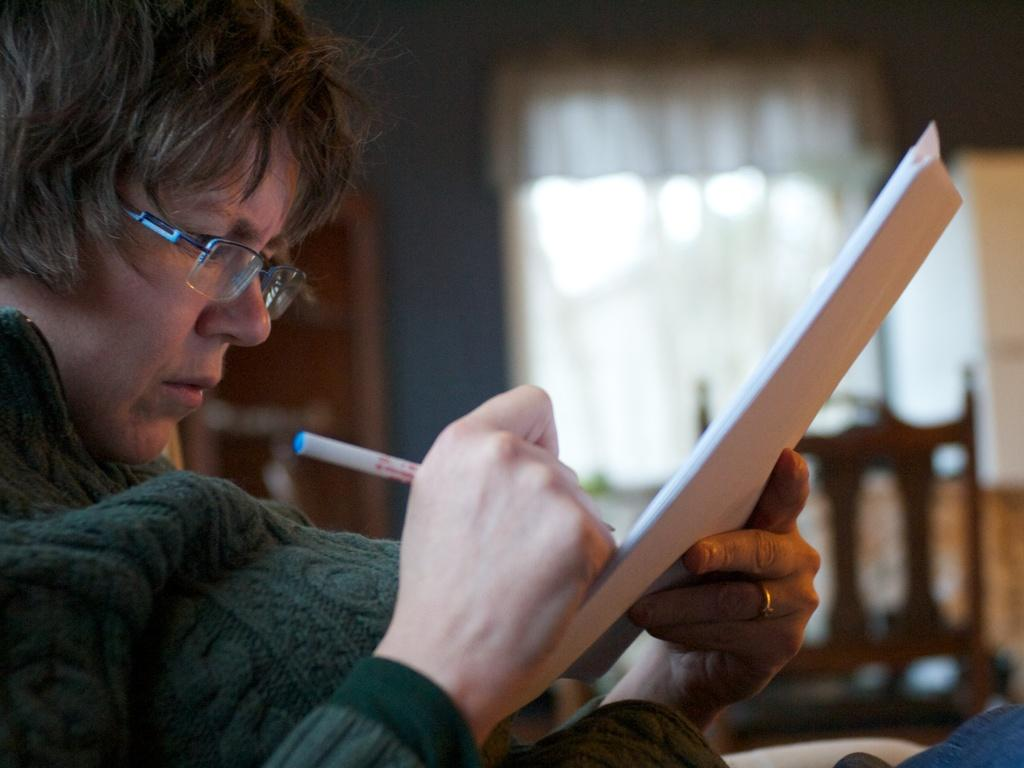Who is present in the image? There is a person in the image. What can be observed about the person's appearance? The person is wearing spectacles. What activity is the person engaged in? The person is writing in a book. What tool is the person using to write? The person is using a pen to write. What object can be seen in the background of the image? There is a chair in the background of the image. What is the sea level in the image? There is no reference to sea level or any body of water in the image, so it cannot be determined. 